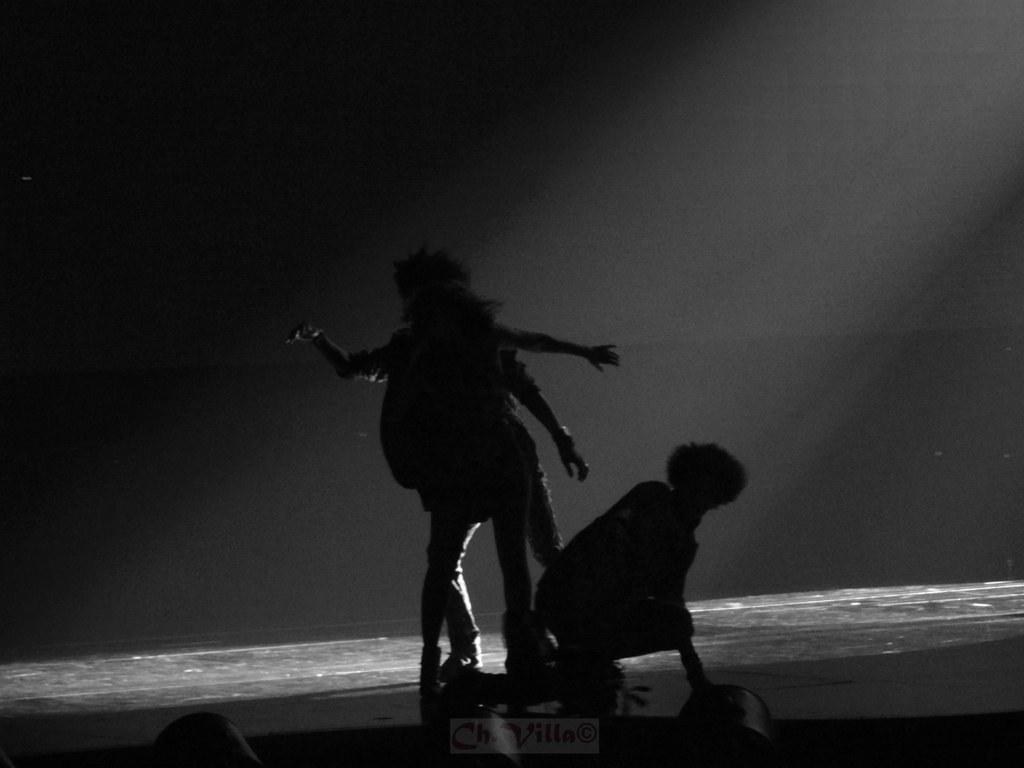What is the setting of the image? The setting of the image is a stage where two persons are standing. Can you describe the posture of one of the persons in the image? Yes, there is a man bending in the image. What type of toothbrush is the man using on the stage? There is no toothbrush present in the image. Can you tell me how many basketballs are visible on the stage? There are no basketballs visible on the stage. What type of mountain range can be seen in the background of the image? There is no mountain range present in the image. 